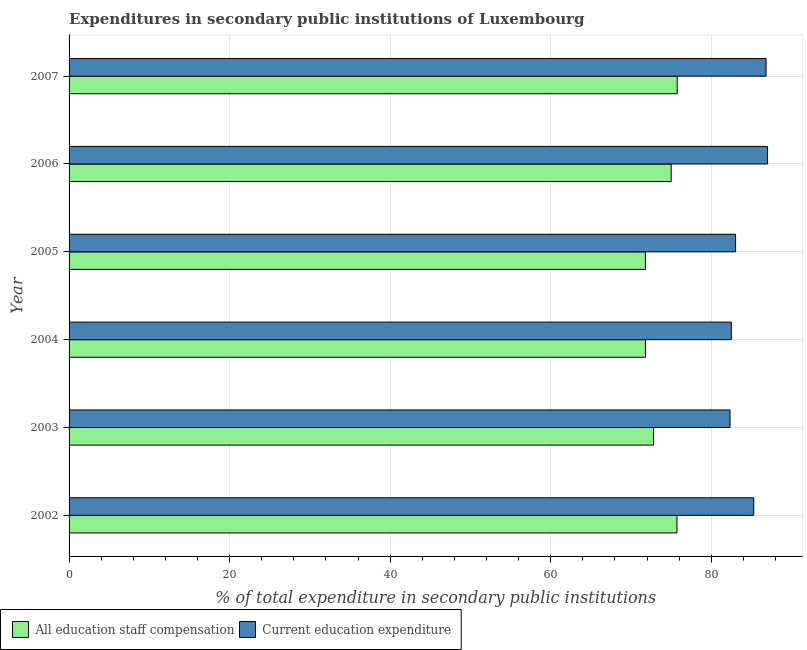Are the number of bars on each tick of the Y-axis equal?
Your answer should be very brief. Yes. How many bars are there on the 2nd tick from the top?
Your answer should be compact. 2. How many bars are there on the 3rd tick from the bottom?
Your response must be concise. 2. What is the label of the 4th group of bars from the top?
Keep it short and to the point. 2004. What is the expenditure in education in 2007?
Keep it short and to the point. 86.83. Across all years, what is the maximum expenditure in education?
Offer a terse response. 87.01. Across all years, what is the minimum expenditure in education?
Provide a short and direct response. 82.34. In which year was the expenditure in education minimum?
Offer a very short reply. 2003. What is the total expenditure in education in the graph?
Keep it short and to the point. 507. What is the difference between the expenditure in education in 2002 and that in 2005?
Make the answer very short. 2.26. What is the difference between the expenditure in staff compensation in 2004 and the expenditure in education in 2007?
Your answer should be compact. -15.02. What is the average expenditure in staff compensation per year?
Offer a very short reply. 73.82. In the year 2006, what is the difference between the expenditure in education and expenditure in staff compensation?
Your answer should be very brief. 12.01. In how many years, is the expenditure in education greater than 24 %?
Keep it short and to the point. 6. What is the ratio of the expenditure in staff compensation in 2006 to that in 2007?
Offer a very short reply. 0.99. Is the expenditure in staff compensation in 2004 less than that in 2007?
Provide a succinct answer. Yes. Is the difference between the expenditure in staff compensation in 2003 and 2007 greater than the difference between the expenditure in education in 2003 and 2007?
Offer a terse response. Yes. What is the difference between the highest and the second highest expenditure in staff compensation?
Give a very brief answer. 0.03. What is the difference between the highest and the lowest expenditure in staff compensation?
Make the answer very short. 3.96. In how many years, is the expenditure in education greater than the average expenditure in education taken over all years?
Keep it short and to the point. 3. What does the 1st bar from the top in 2006 represents?
Provide a short and direct response. Current education expenditure. What does the 2nd bar from the bottom in 2002 represents?
Offer a terse response. Current education expenditure. Does the graph contain any zero values?
Ensure brevity in your answer.  No. Does the graph contain grids?
Give a very brief answer. Yes. How many legend labels are there?
Your answer should be compact. 2. What is the title of the graph?
Ensure brevity in your answer.  Expenditures in secondary public institutions of Luxembourg. What is the label or title of the X-axis?
Ensure brevity in your answer.  % of total expenditure in secondary public institutions. What is the % of total expenditure in secondary public institutions in All education staff compensation in 2002?
Keep it short and to the point. 75.73. What is the % of total expenditure in secondary public institutions of Current education expenditure in 2002?
Ensure brevity in your answer.  85.29. What is the % of total expenditure in secondary public institutions of All education staff compensation in 2003?
Offer a very short reply. 72.81. What is the % of total expenditure in secondary public institutions in Current education expenditure in 2003?
Your answer should be very brief. 82.34. What is the % of total expenditure in secondary public institutions of All education staff compensation in 2004?
Give a very brief answer. 71.81. What is the % of total expenditure in secondary public institutions of Current education expenditure in 2004?
Keep it short and to the point. 82.5. What is the % of total expenditure in secondary public institutions of All education staff compensation in 2005?
Your answer should be compact. 71.8. What is the % of total expenditure in secondary public institutions of Current education expenditure in 2005?
Your answer should be very brief. 83.03. What is the % of total expenditure in secondary public institutions in All education staff compensation in 2006?
Provide a short and direct response. 75.01. What is the % of total expenditure in secondary public institutions of Current education expenditure in 2006?
Ensure brevity in your answer.  87.01. What is the % of total expenditure in secondary public institutions in All education staff compensation in 2007?
Your response must be concise. 75.76. What is the % of total expenditure in secondary public institutions in Current education expenditure in 2007?
Provide a succinct answer. 86.83. Across all years, what is the maximum % of total expenditure in secondary public institutions of All education staff compensation?
Offer a terse response. 75.76. Across all years, what is the maximum % of total expenditure in secondary public institutions of Current education expenditure?
Offer a terse response. 87.01. Across all years, what is the minimum % of total expenditure in secondary public institutions in All education staff compensation?
Your response must be concise. 71.8. Across all years, what is the minimum % of total expenditure in secondary public institutions in Current education expenditure?
Give a very brief answer. 82.34. What is the total % of total expenditure in secondary public institutions of All education staff compensation in the graph?
Offer a very short reply. 442.91. What is the total % of total expenditure in secondary public institutions of Current education expenditure in the graph?
Offer a terse response. 507. What is the difference between the % of total expenditure in secondary public institutions of All education staff compensation in 2002 and that in 2003?
Give a very brief answer. 2.91. What is the difference between the % of total expenditure in secondary public institutions in Current education expenditure in 2002 and that in 2003?
Your response must be concise. 2.96. What is the difference between the % of total expenditure in secondary public institutions of All education staff compensation in 2002 and that in 2004?
Your answer should be compact. 3.92. What is the difference between the % of total expenditure in secondary public institutions of Current education expenditure in 2002 and that in 2004?
Give a very brief answer. 2.79. What is the difference between the % of total expenditure in secondary public institutions in All education staff compensation in 2002 and that in 2005?
Offer a terse response. 3.93. What is the difference between the % of total expenditure in secondary public institutions of Current education expenditure in 2002 and that in 2005?
Your response must be concise. 2.26. What is the difference between the % of total expenditure in secondary public institutions of All education staff compensation in 2002 and that in 2006?
Your answer should be very brief. 0.72. What is the difference between the % of total expenditure in secondary public institutions in Current education expenditure in 2002 and that in 2006?
Your answer should be very brief. -1.72. What is the difference between the % of total expenditure in secondary public institutions in All education staff compensation in 2002 and that in 2007?
Give a very brief answer. -0.03. What is the difference between the % of total expenditure in secondary public institutions in Current education expenditure in 2002 and that in 2007?
Keep it short and to the point. -1.54. What is the difference between the % of total expenditure in secondary public institutions in All education staff compensation in 2003 and that in 2004?
Provide a short and direct response. 1. What is the difference between the % of total expenditure in secondary public institutions in Current education expenditure in 2003 and that in 2004?
Offer a very short reply. -0.16. What is the difference between the % of total expenditure in secondary public institutions in All education staff compensation in 2003 and that in 2005?
Keep it short and to the point. 1.02. What is the difference between the % of total expenditure in secondary public institutions of Current education expenditure in 2003 and that in 2005?
Ensure brevity in your answer.  -0.69. What is the difference between the % of total expenditure in secondary public institutions of All education staff compensation in 2003 and that in 2006?
Your answer should be very brief. -2.19. What is the difference between the % of total expenditure in secondary public institutions in Current education expenditure in 2003 and that in 2006?
Give a very brief answer. -4.68. What is the difference between the % of total expenditure in secondary public institutions in All education staff compensation in 2003 and that in 2007?
Your answer should be compact. -2.94. What is the difference between the % of total expenditure in secondary public institutions of Current education expenditure in 2003 and that in 2007?
Give a very brief answer. -4.49. What is the difference between the % of total expenditure in secondary public institutions in All education staff compensation in 2004 and that in 2005?
Provide a succinct answer. 0.01. What is the difference between the % of total expenditure in secondary public institutions in Current education expenditure in 2004 and that in 2005?
Keep it short and to the point. -0.53. What is the difference between the % of total expenditure in secondary public institutions in All education staff compensation in 2004 and that in 2006?
Keep it short and to the point. -3.2. What is the difference between the % of total expenditure in secondary public institutions in Current education expenditure in 2004 and that in 2006?
Make the answer very short. -4.51. What is the difference between the % of total expenditure in secondary public institutions in All education staff compensation in 2004 and that in 2007?
Make the answer very short. -3.95. What is the difference between the % of total expenditure in secondary public institutions of Current education expenditure in 2004 and that in 2007?
Provide a short and direct response. -4.33. What is the difference between the % of total expenditure in secondary public institutions of All education staff compensation in 2005 and that in 2006?
Offer a terse response. -3.21. What is the difference between the % of total expenditure in secondary public institutions of Current education expenditure in 2005 and that in 2006?
Keep it short and to the point. -3.99. What is the difference between the % of total expenditure in secondary public institutions in All education staff compensation in 2005 and that in 2007?
Offer a very short reply. -3.96. What is the difference between the % of total expenditure in secondary public institutions of Current education expenditure in 2005 and that in 2007?
Give a very brief answer. -3.8. What is the difference between the % of total expenditure in secondary public institutions in All education staff compensation in 2006 and that in 2007?
Keep it short and to the point. -0.75. What is the difference between the % of total expenditure in secondary public institutions in Current education expenditure in 2006 and that in 2007?
Offer a very short reply. 0.19. What is the difference between the % of total expenditure in secondary public institutions of All education staff compensation in 2002 and the % of total expenditure in secondary public institutions of Current education expenditure in 2003?
Your answer should be very brief. -6.61. What is the difference between the % of total expenditure in secondary public institutions in All education staff compensation in 2002 and the % of total expenditure in secondary public institutions in Current education expenditure in 2004?
Give a very brief answer. -6.77. What is the difference between the % of total expenditure in secondary public institutions of All education staff compensation in 2002 and the % of total expenditure in secondary public institutions of Current education expenditure in 2005?
Provide a succinct answer. -7.3. What is the difference between the % of total expenditure in secondary public institutions in All education staff compensation in 2002 and the % of total expenditure in secondary public institutions in Current education expenditure in 2006?
Offer a terse response. -11.29. What is the difference between the % of total expenditure in secondary public institutions in All education staff compensation in 2002 and the % of total expenditure in secondary public institutions in Current education expenditure in 2007?
Your answer should be very brief. -11.1. What is the difference between the % of total expenditure in secondary public institutions of All education staff compensation in 2003 and the % of total expenditure in secondary public institutions of Current education expenditure in 2004?
Provide a succinct answer. -9.68. What is the difference between the % of total expenditure in secondary public institutions in All education staff compensation in 2003 and the % of total expenditure in secondary public institutions in Current education expenditure in 2005?
Keep it short and to the point. -10.21. What is the difference between the % of total expenditure in secondary public institutions of All education staff compensation in 2003 and the % of total expenditure in secondary public institutions of Current education expenditure in 2006?
Keep it short and to the point. -14.2. What is the difference between the % of total expenditure in secondary public institutions in All education staff compensation in 2003 and the % of total expenditure in secondary public institutions in Current education expenditure in 2007?
Provide a short and direct response. -14.01. What is the difference between the % of total expenditure in secondary public institutions of All education staff compensation in 2004 and the % of total expenditure in secondary public institutions of Current education expenditure in 2005?
Make the answer very short. -11.22. What is the difference between the % of total expenditure in secondary public institutions in All education staff compensation in 2004 and the % of total expenditure in secondary public institutions in Current education expenditure in 2006?
Offer a terse response. -15.2. What is the difference between the % of total expenditure in secondary public institutions in All education staff compensation in 2004 and the % of total expenditure in secondary public institutions in Current education expenditure in 2007?
Provide a succinct answer. -15.02. What is the difference between the % of total expenditure in secondary public institutions in All education staff compensation in 2005 and the % of total expenditure in secondary public institutions in Current education expenditure in 2006?
Your answer should be compact. -15.22. What is the difference between the % of total expenditure in secondary public institutions of All education staff compensation in 2005 and the % of total expenditure in secondary public institutions of Current education expenditure in 2007?
Your answer should be compact. -15.03. What is the difference between the % of total expenditure in secondary public institutions in All education staff compensation in 2006 and the % of total expenditure in secondary public institutions in Current education expenditure in 2007?
Keep it short and to the point. -11.82. What is the average % of total expenditure in secondary public institutions in All education staff compensation per year?
Provide a short and direct response. 73.82. What is the average % of total expenditure in secondary public institutions of Current education expenditure per year?
Ensure brevity in your answer.  84.5. In the year 2002, what is the difference between the % of total expenditure in secondary public institutions of All education staff compensation and % of total expenditure in secondary public institutions of Current education expenditure?
Offer a very short reply. -9.57. In the year 2003, what is the difference between the % of total expenditure in secondary public institutions of All education staff compensation and % of total expenditure in secondary public institutions of Current education expenditure?
Give a very brief answer. -9.52. In the year 2004, what is the difference between the % of total expenditure in secondary public institutions of All education staff compensation and % of total expenditure in secondary public institutions of Current education expenditure?
Offer a very short reply. -10.69. In the year 2005, what is the difference between the % of total expenditure in secondary public institutions of All education staff compensation and % of total expenditure in secondary public institutions of Current education expenditure?
Offer a terse response. -11.23. In the year 2006, what is the difference between the % of total expenditure in secondary public institutions in All education staff compensation and % of total expenditure in secondary public institutions in Current education expenditure?
Give a very brief answer. -12.01. In the year 2007, what is the difference between the % of total expenditure in secondary public institutions in All education staff compensation and % of total expenditure in secondary public institutions in Current education expenditure?
Give a very brief answer. -11.07. What is the ratio of the % of total expenditure in secondary public institutions in All education staff compensation in 2002 to that in 2003?
Offer a terse response. 1.04. What is the ratio of the % of total expenditure in secondary public institutions of Current education expenditure in 2002 to that in 2003?
Make the answer very short. 1.04. What is the ratio of the % of total expenditure in secondary public institutions of All education staff compensation in 2002 to that in 2004?
Your response must be concise. 1.05. What is the ratio of the % of total expenditure in secondary public institutions of Current education expenditure in 2002 to that in 2004?
Provide a succinct answer. 1.03. What is the ratio of the % of total expenditure in secondary public institutions in All education staff compensation in 2002 to that in 2005?
Provide a short and direct response. 1.05. What is the ratio of the % of total expenditure in secondary public institutions of Current education expenditure in 2002 to that in 2005?
Offer a very short reply. 1.03. What is the ratio of the % of total expenditure in secondary public institutions of All education staff compensation in 2002 to that in 2006?
Your response must be concise. 1.01. What is the ratio of the % of total expenditure in secondary public institutions of Current education expenditure in 2002 to that in 2006?
Make the answer very short. 0.98. What is the ratio of the % of total expenditure in secondary public institutions in All education staff compensation in 2002 to that in 2007?
Your answer should be very brief. 1. What is the ratio of the % of total expenditure in secondary public institutions in Current education expenditure in 2002 to that in 2007?
Provide a short and direct response. 0.98. What is the ratio of the % of total expenditure in secondary public institutions in All education staff compensation in 2003 to that in 2004?
Your answer should be compact. 1.01. What is the ratio of the % of total expenditure in secondary public institutions of Current education expenditure in 2003 to that in 2004?
Keep it short and to the point. 1. What is the ratio of the % of total expenditure in secondary public institutions in All education staff compensation in 2003 to that in 2005?
Give a very brief answer. 1.01. What is the ratio of the % of total expenditure in secondary public institutions in Current education expenditure in 2003 to that in 2005?
Offer a very short reply. 0.99. What is the ratio of the % of total expenditure in secondary public institutions of All education staff compensation in 2003 to that in 2006?
Make the answer very short. 0.97. What is the ratio of the % of total expenditure in secondary public institutions of Current education expenditure in 2003 to that in 2006?
Keep it short and to the point. 0.95. What is the ratio of the % of total expenditure in secondary public institutions of All education staff compensation in 2003 to that in 2007?
Your answer should be very brief. 0.96. What is the ratio of the % of total expenditure in secondary public institutions of Current education expenditure in 2003 to that in 2007?
Provide a short and direct response. 0.95. What is the ratio of the % of total expenditure in secondary public institutions of Current education expenditure in 2004 to that in 2005?
Your answer should be compact. 0.99. What is the ratio of the % of total expenditure in secondary public institutions of All education staff compensation in 2004 to that in 2006?
Offer a very short reply. 0.96. What is the ratio of the % of total expenditure in secondary public institutions in Current education expenditure in 2004 to that in 2006?
Ensure brevity in your answer.  0.95. What is the ratio of the % of total expenditure in secondary public institutions in All education staff compensation in 2004 to that in 2007?
Give a very brief answer. 0.95. What is the ratio of the % of total expenditure in secondary public institutions in Current education expenditure in 2004 to that in 2007?
Offer a terse response. 0.95. What is the ratio of the % of total expenditure in secondary public institutions of All education staff compensation in 2005 to that in 2006?
Provide a succinct answer. 0.96. What is the ratio of the % of total expenditure in secondary public institutions of Current education expenditure in 2005 to that in 2006?
Make the answer very short. 0.95. What is the ratio of the % of total expenditure in secondary public institutions of All education staff compensation in 2005 to that in 2007?
Give a very brief answer. 0.95. What is the ratio of the % of total expenditure in secondary public institutions of Current education expenditure in 2005 to that in 2007?
Give a very brief answer. 0.96. What is the difference between the highest and the second highest % of total expenditure in secondary public institutions in All education staff compensation?
Make the answer very short. 0.03. What is the difference between the highest and the second highest % of total expenditure in secondary public institutions in Current education expenditure?
Your response must be concise. 0.19. What is the difference between the highest and the lowest % of total expenditure in secondary public institutions in All education staff compensation?
Give a very brief answer. 3.96. What is the difference between the highest and the lowest % of total expenditure in secondary public institutions in Current education expenditure?
Ensure brevity in your answer.  4.68. 